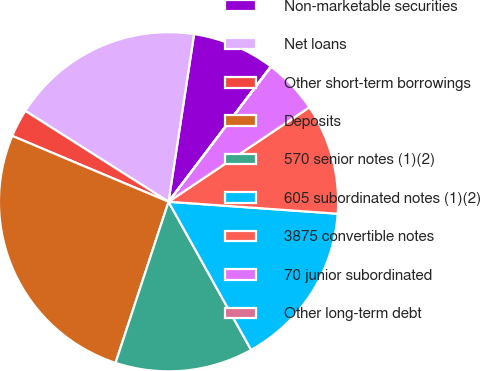<chart> <loc_0><loc_0><loc_500><loc_500><pie_chart><fcel>Non-marketable securities<fcel>Net loans<fcel>Other short-term borrowings<fcel>Deposits<fcel>570 senior notes (1)(2)<fcel>605 subordinated notes (1)(2)<fcel>3875 convertible notes<fcel>70 junior subordinated<fcel>Other long-term debt<nl><fcel>7.9%<fcel>18.41%<fcel>2.65%<fcel>26.29%<fcel>13.15%<fcel>15.78%<fcel>10.53%<fcel>5.27%<fcel>0.02%<nl></chart> 